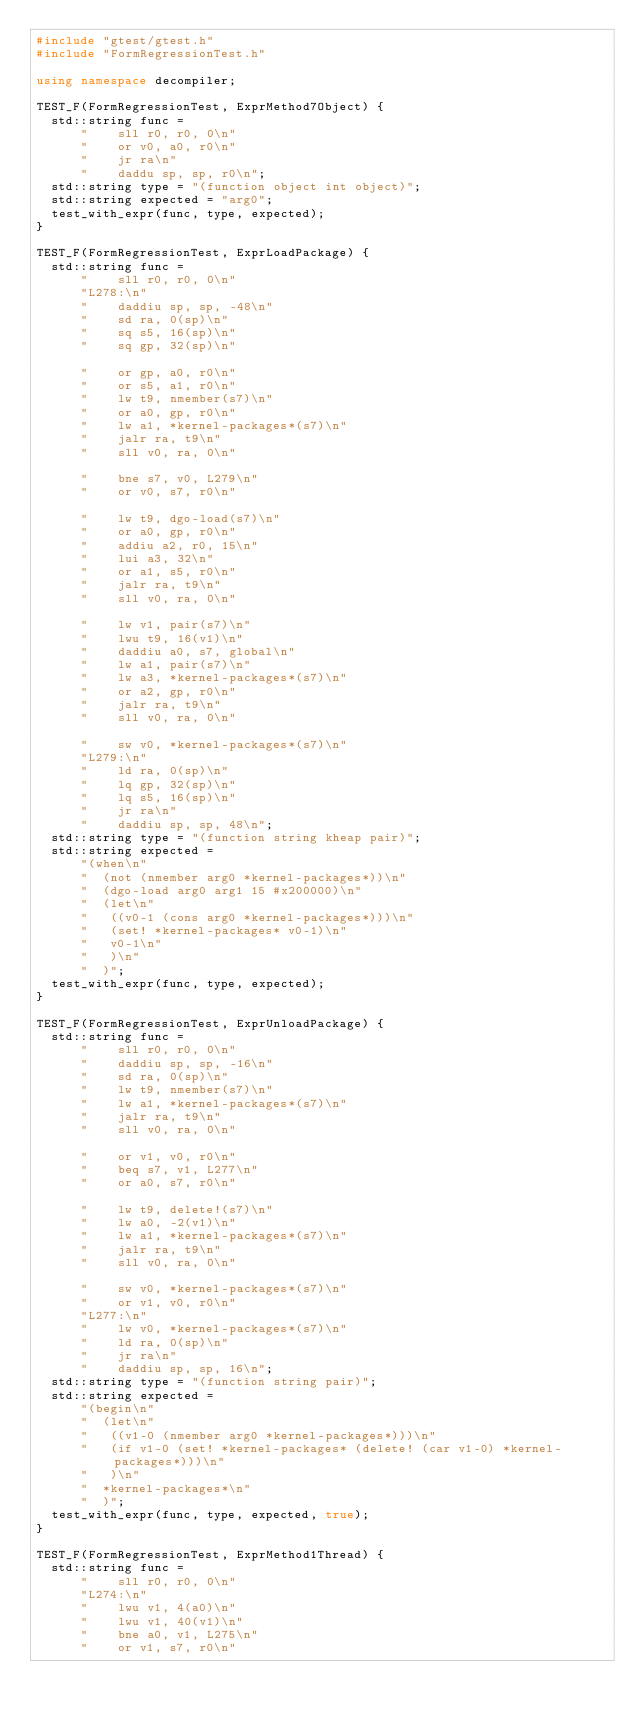Convert code to text. <code><loc_0><loc_0><loc_500><loc_500><_C++_>#include "gtest/gtest.h"
#include "FormRegressionTest.h"

using namespace decompiler;

TEST_F(FormRegressionTest, ExprMethod7Object) {
  std::string func =
      "    sll r0, r0, 0\n"
      "    or v0, a0, r0\n"
      "    jr ra\n"
      "    daddu sp, sp, r0\n";
  std::string type = "(function object int object)";
  std::string expected = "arg0";
  test_with_expr(func, type, expected);
}

TEST_F(FormRegressionTest, ExprLoadPackage) {
  std::string func =
      "    sll r0, r0, 0\n"
      "L278:\n"
      "    daddiu sp, sp, -48\n"
      "    sd ra, 0(sp)\n"
      "    sq s5, 16(sp)\n"
      "    sq gp, 32(sp)\n"

      "    or gp, a0, r0\n"
      "    or s5, a1, r0\n"
      "    lw t9, nmember(s7)\n"
      "    or a0, gp, r0\n"
      "    lw a1, *kernel-packages*(s7)\n"
      "    jalr ra, t9\n"
      "    sll v0, ra, 0\n"

      "    bne s7, v0, L279\n"
      "    or v0, s7, r0\n"

      "    lw t9, dgo-load(s7)\n"
      "    or a0, gp, r0\n"
      "    addiu a2, r0, 15\n"
      "    lui a3, 32\n"
      "    or a1, s5, r0\n"
      "    jalr ra, t9\n"
      "    sll v0, ra, 0\n"

      "    lw v1, pair(s7)\n"
      "    lwu t9, 16(v1)\n"
      "    daddiu a0, s7, global\n"
      "    lw a1, pair(s7)\n"
      "    lw a3, *kernel-packages*(s7)\n"
      "    or a2, gp, r0\n"
      "    jalr ra, t9\n"
      "    sll v0, ra, 0\n"

      "    sw v0, *kernel-packages*(s7)\n"
      "L279:\n"
      "    ld ra, 0(sp)\n"
      "    lq gp, 32(sp)\n"
      "    lq s5, 16(sp)\n"
      "    jr ra\n"
      "    daddiu sp, sp, 48\n";
  std::string type = "(function string kheap pair)";
  std::string expected =
      "(when\n"
      "  (not (nmember arg0 *kernel-packages*))\n"
      "  (dgo-load arg0 arg1 15 #x200000)\n"
      "  (let\n"
      "   ((v0-1 (cons arg0 *kernel-packages*)))\n"
      "   (set! *kernel-packages* v0-1)\n"
      "   v0-1\n"
      "   )\n"
      "  )";
  test_with_expr(func, type, expected);
}

TEST_F(FormRegressionTest, ExprUnloadPackage) {
  std::string func =
      "    sll r0, r0, 0\n"
      "    daddiu sp, sp, -16\n"
      "    sd ra, 0(sp)\n"
      "    lw t9, nmember(s7)\n"
      "    lw a1, *kernel-packages*(s7)\n"
      "    jalr ra, t9\n"
      "    sll v0, ra, 0\n"

      "    or v1, v0, r0\n"
      "    beq s7, v1, L277\n"
      "    or a0, s7, r0\n"

      "    lw t9, delete!(s7)\n"
      "    lw a0, -2(v1)\n"
      "    lw a1, *kernel-packages*(s7)\n"
      "    jalr ra, t9\n"
      "    sll v0, ra, 0\n"

      "    sw v0, *kernel-packages*(s7)\n"
      "    or v1, v0, r0\n"
      "L277:\n"
      "    lw v0, *kernel-packages*(s7)\n"
      "    ld ra, 0(sp)\n"
      "    jr ra\n"
      "    daddiu sp, sp, 16\n";
  std::string type = "(function string pair)";
  std::string expected =
      "(begin\n"
      "  (let\n"
      "   ((v1-0 (nmember arg0 *kernel-packages*)))\n"
      "   (if v1-0 (set! *kernel-packages* (delete! (car v1-0) *kernel-packages*)))\n"
      "   )\n"
      "  *kernel-packages*\n"
      "  )";
  test_with_expr(func, type, expected, true);
}

TEST_F(FormRegressionTest, ExprMethod1Thread) {
  std::string func =
      "    sll r0, r0, 0\n"
      "L274:\n"
      "    lwu v1, 4(a0)\n"
      "    lwu v1, 40(v1)\n"
      "    bne a0, v1, L275\n"
      "    or v1, s7, r0\n"
</code> 